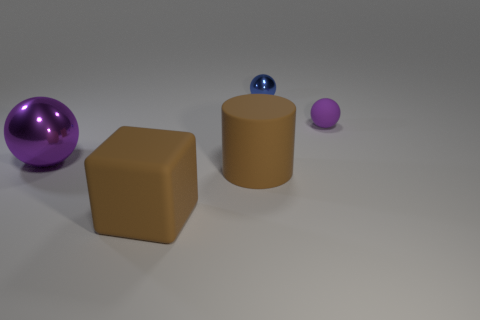Subtract all tiny spheres. How many spheres are left? 1 Subtract all blue balls. How many balls are left? 2 Subtract all cubes. How many objects are left? 4 Subtract 0 green cylinders. How many objects are left? 5 Subtract 1 blocks. How many blocks are left? 0 Subtract all cyan blocks. Subtract all brown cylinders. How many blocks are left? 1 Subtract all cyan cylinders. How many purple spheres are left? 2 Subtract all large blocks. Subtract all brown matte things. How many objects are left? 2 Add 1 big brown cylinders. How many big brown cylinders are left? 2 Add 4 purple matte spheres. How many purple matte spheres exist? 5 